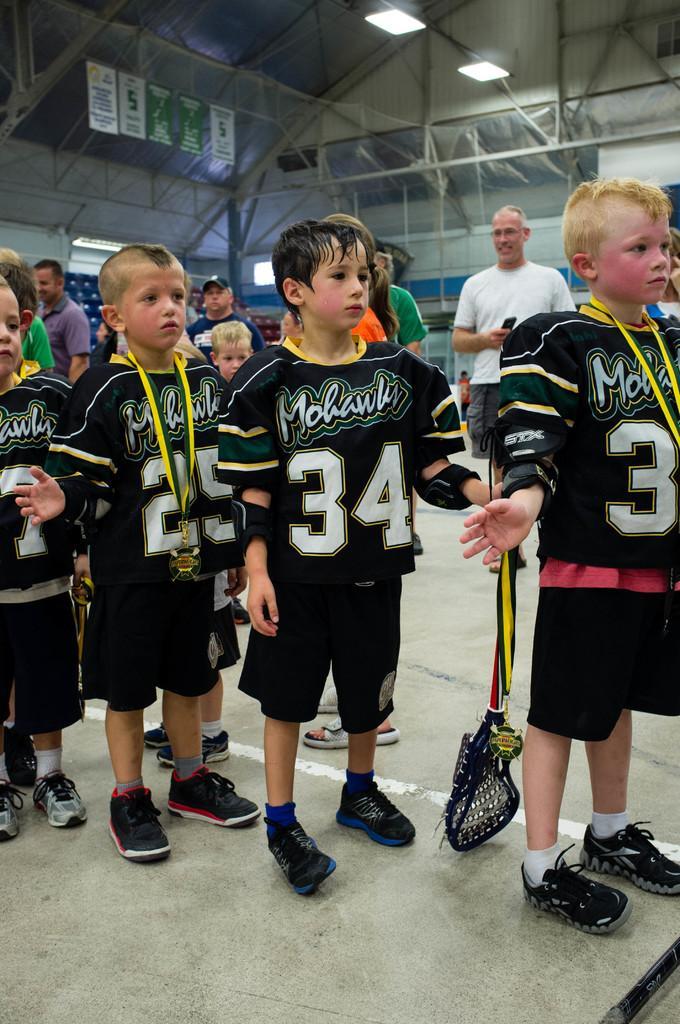Could you give a brief overview of what you see in this image? There is a group of persons standing as we can see in the middle of this image. There is a net and a wall in the background. There are two lights at the top of this image. 